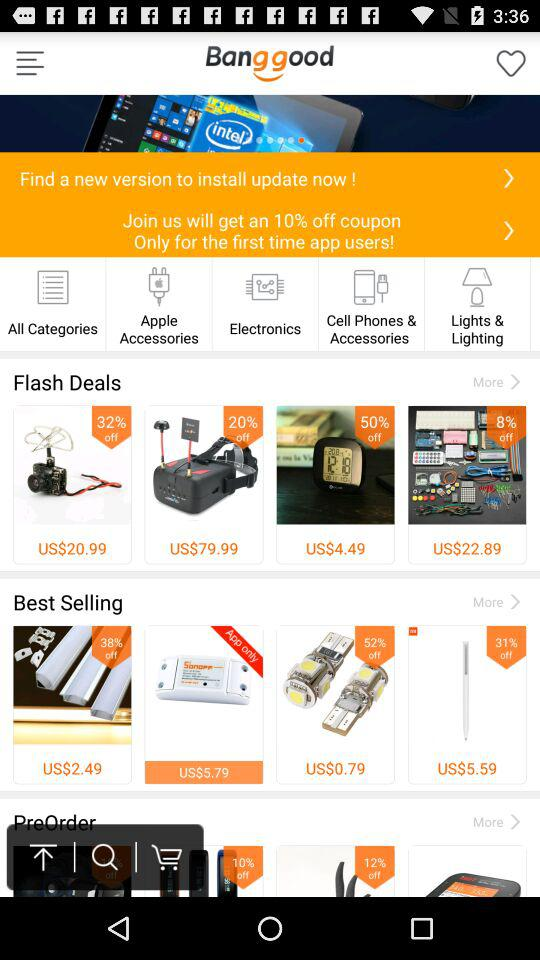What is the percentage off on joining Bang good? The percentage off is 10. 